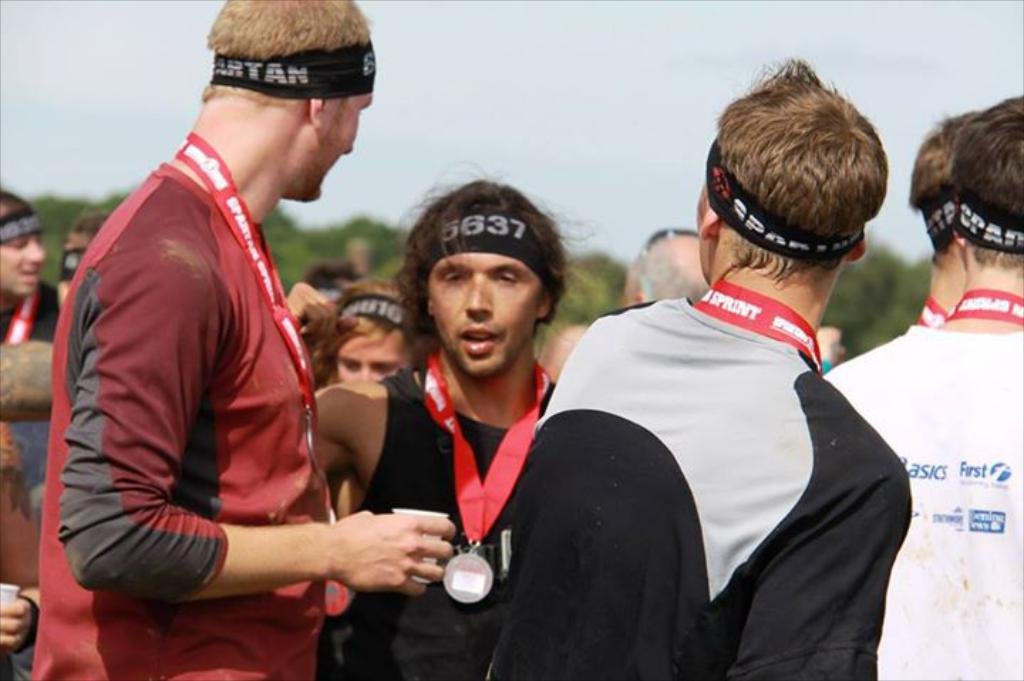What is the main subject of the image? The main subject of the image is a group of men. What are the men wearing on their heads? The men are wearing bands on their heads. What type of jewelry are the men wearing around their necks? The men are wearing metals around their necks. How would you describe the background of the image? The background of the men is blurred. What type of grass can be seen growing in the image? There is no grass present in the image; it features a group of men with blurred backgrounds. 